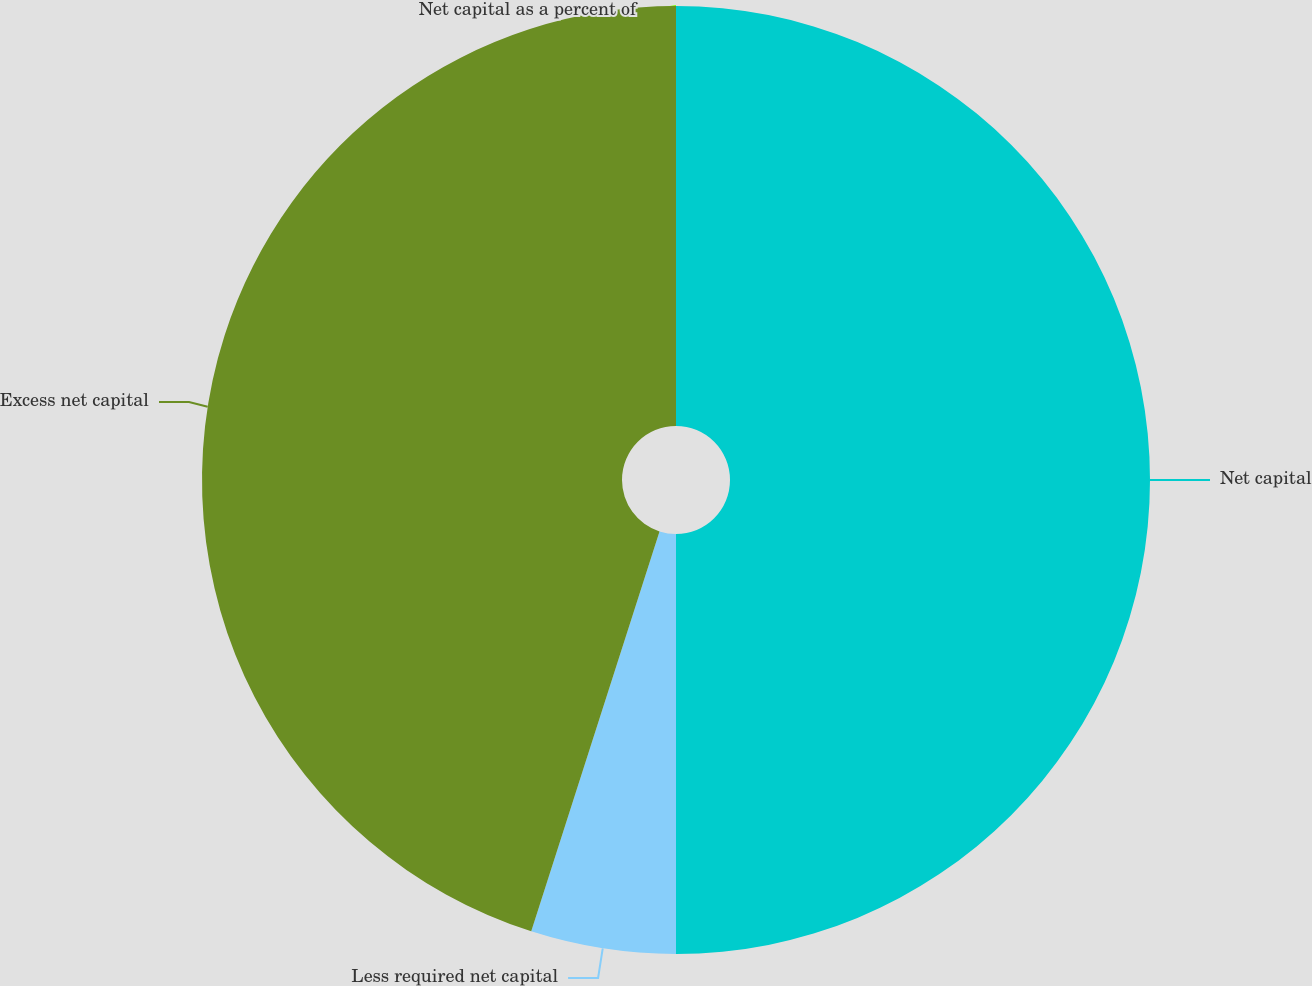Convert chart to OTSL. <chart><loc_0><loc_0><loc_500><loc_500><pie_chart><fcel>Net capital as a percent of<fcel>Net capital<fcel>Less required net capital<fcel>Excess net capital<nl><fcel>0.0%<fcel>50.0%<fcel>4.94%<fcel>45.06%<nl></chart> 